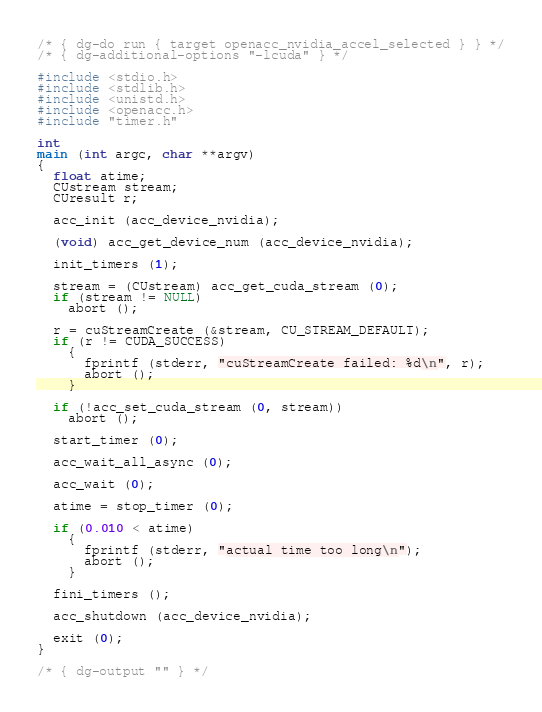Convert code to text. <code><loc_0><loc_0><loc_500><loc_500><_C_>/* { dg-do run { target openacc_nvidia_accel_selected } } */
/* { dg-additional-options "-lcuda" } */

#include <stdio.h>
#include <stdlib.h>
#include <unistd.h>
#include <openacc.h>
#include "timer.h"

int
main (int argc, char **argv)
{
  float atime;
  CUstream stream;
  CUresult r;

  acc_init (acc_device_nvidia);

  (void) acc_get_device_num (acc_device_nvidia);

  init_timers (1);

  stream = (CUstream) acc_get_cuda_stream (0);
  if (stream != NULL)
    abort ();

  r = cuStreamCreate (&stream, CU_STREAM_DEFAULT);
  if (r != CUDA_SUCCESS)
    {
      fprintf (stderr, "cuStreamCreate failed: %d\n", r);
      abort ();
    }

  if (!acc_set_cuda_stream (0, stream))
    abort ();

  start_timer (0);

  acc_wait_all_async (0);

  acc_wait (0);

  atime = stop_timer (0);

  if (0.010 < atime)
    {
      fprintf (stderr, "actual time too long\n");
      abort ();
    }

  fini_timers ();

  acc_shutdown (acc_device_nvidia);

  exit (0);
}

/* { dg-output "" } */
</code> 